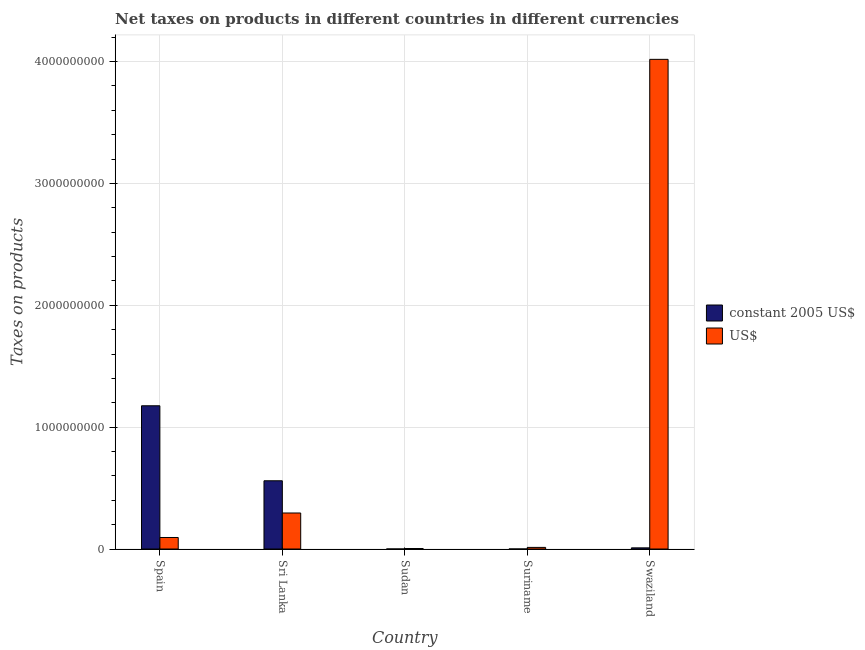How many different coloured bars are there?
Your answer should be very brief. 2. How many groups of bars are there?
Ensure brevity in your answer.  5. How many bars are there on the 3rd tick from the left?
Give a very brief answer. 2. How many bars are there on the 4th tick from the right?
Offer a very short reply. 2. What is the label of the 4th group of bars from the left?
Offer a terse response. Suriname. In how many cases, is the number of bars for a given country not equal to the number of legend labels?
Provide a succinct answer. 0. What is the net taxes in us$ in Sri Lanka?
Offer a terse response. 2.96e+08. Across all countries, what is the maximum net taxes in us$?
Provide a succinct answer. 4.02e+09. Across all countries, what is the minimum net taxes in us$?
Offer a terse response. 4.10e+06. In which country was the net taxes in constant 2005 us$ maximum?
Your answer should be very brief. Spain. In which country was the net taxes in us$ minimum?
Your answer should be compact. Sudan. What is the total net taxes in us$ in the graph?
Your response must be concise. 4.43e+09. What is the difference between the net taxes in constant 2005 us$ in Sudan and that in Swaziland?
Offer a very short reply. -9.30e+06. What is the difference between the net taxes in us$ in Swaziland and the net taxes in constant 2005 us$ in Sri Lanka?
Give a very brief answer. 3.46e+09. What is the average net taxes in constant 2005 us$ per country?
Ensure brevity in your answer.  3.49e+08. What is the difference between the net taxes in constant 2005 us$ and net taxes in us$ in Swaziland?
Provide a short and direct response. -4.01e+09. What is the ratio of the net taxes in us$ in Sri Lanka to that in Swaziland?
Offer a very short reply. 0.07. Is the net taxes in constant 2005 us$ in Sri Lanka less than that in Suriname?
Keep it short and to the point. No. Is the difference between the net taxes in us$ in Spain and Swaziland greater than the difference between the net taxes in constant 2005 us$ in Spain and Swaziland?
Offer a very short reply. No. What is the difference between the highest and the second highest net taxes in us$?
Your answer should be very brief. 3.72e+09. What is the difference between the highest and the lowest net taxes in us$?
Your answer should be compact. 4.01e+09. In how many countries, is the net taxes in us$ greater than the average net taxes in us$ taken over all countries?
Offer a very short reply. 1. Is the sum of the net taxes in us$ in Sudan and Suriname greater than the maximum net taxes in constant 2005 us$ across all countries?
Your answer should be very brief. No. What does the 1st bar from the left in Sudan represents?
Make the answer very short. Constant 2005 us$. What does the 2nd bar from the right in Sri Lanka represents?
Give a very brief answer. Constant 2005 us$. How many bars are there?
Ensure brevity in your answer.  10. Are all the bars in the graph horizontal?
Make the answer very short. No. How many countries are there in the graph?
Your answer should be very brief. 5. Are the values on the major ticks of Y-axis written in scientific E-notation?
Give a very brief answer. No. Does the graph contain any zero values?
Your response must be concise. No. Does the graph contain grids?
Your response must be concise. Yes. How many legend labels are there?
Provide a succinct answer. 2. What is the title of the graph?
Your response must be concise. Net taxes on products in different countries in different currencies. What is the label or title of the X-axis?
Offer a very short reply. Country. What is the label or title of the Y-axis?
Provide a short and direct response. Taxes on products. What is the Taxes on products in constant 2005 US$ in Spain?
Make the answer very short. 1.18e+09. What is the Taxes on products in US$ in Spain?
Offer a very short reply. 9.44e+07. What is the Taxes on products in constant 2005 US$ in Sri Lanka?
Your response must be concise. 5.60e+08. What is the Taxes on products in US$ in Sri Lanka?
Offer a terse response. 2.96e+08. What is the Taxes on products in constant 2005 US$ in Sudan?
Give a very brief answer. 1.03e+05. What is the Taxes on products in US$ in Sudan?
Make the answer very short. 4.10e+06. What is the Taxes on products of constant 2005 US$ in Suriname?
Offer a terse response. 8200. What is the Taxes on products of US$ in Suriname?
Give a very brief answer. 1.31e+07. What is the Taxes on products of constant 2005 US$ in Swaziland?
Provide a short and direct response. 9.40e+06. What is the Taxes on products of US$ in Swaziland?
Keep it short and to the point. 4.02e+09. Across all countries, what is the maximum Taxes on products in constant 2005 US$?
Give a very brief answer. 1.18e+09. Across all countries, what is the maximum Taxes on products in US$?
Make the answer very short. 4.02e+09. Across all countries, what is the minimum Taxes on products of constant 2005 US$?
Provide a succinct answer. 8200. Across all countries, what is the minimum Taxes on products of US$?
Offer a terse response. 4.10e+06. What is the total Taxes on products of constant 2005 US$ in the graph?
Your response must be concise. 1.74e+09. What is the total Taxes on products of US$ in the graph?
Your answer should be very brief. 4.43e+09. What is the difference between the Taxes on products of constant 2005 US$ in Spain and that in Sri Lanka?
Provide a succinct answer. 6.15e+08. What is the difference between the Taxes on products of US$ in Spain and that in Sri Lanka?
Provide a succinct answer. -2.01e+08. What is the difference between the Taxes on products of constant 2005 US$ in Spain and that in Sudan?
Offer a very short reply. 1.18e+09. What is the difference between the Taxes on products in US$ in Spain and that in Sudan?
Provide a short and direct response. 9.03e+07. What is the difference between the Taxes on products of constant 2005 US$ in Spain and that in Suriname?
Offer a terse response. 1.18e+09. What is the difference between the Taxes on products in US$ in Spain and that in Suriname?
Keep it short and to the point. 8.13e+07. What is the difference between the Taxes on products of constant 2005 US$ in Spain and that in Swaziland?
Your response must be concise. 1.17e+09. What is the difference between the Taxes on products of US$ in Spain and that in Swaziland?
Give a very brief answer. -3.92e+09. What is the difference between the Taxes on products in constant 2005 US$ in Sri Lanka and that in Sudan?
Provide a succinct answer. 5.60e+08. What is the difference between the Taxes on products in US$ in Sri Lanka and that in Sudan?
Offer a terse response. 2.91e+08. What is the difference between the Taxes on products of constant 2005 US$ in Sri Lanka and that in Suriname?
Ensure brevity in your answer.  5.60e+08. What is the difference between the Taxes on products in US$ in Sri Lanka and that in Suriname?
Ensure brevity in your answer.  2.82e+08. What is the difference between the Taxes on products of constant 2005 US$ in Sri Lanka and that in Swaziland?
Your response must be concise. 5.51e+08. What is the difference between the Taxes on products of US$ in Sri Lanka and that in Swaziland?
Make the answer very short. -3.72e+09. What is the difference between the Taxes on products of constant 2005 US$ in Sudan and that in Suriname?
Offer a very short reply. 9.47e+04. What is the difference between the Taxes on products of US$ in Sudan and that in Suriname?
Provide a succinct answer. -9.04e+06. What is the difference between the Taxes on products of constant 2005 US$ in Sudan and that in Swaziland?
Provide a succinct answer. -9.30e+06. What is the difference between the Taxes on products in US$ in Sudan and that in Swaziland?
Offer a very short reply. -4.01e+09. What is the difference between the Taxes on products in constant 2005 US$ in Suriname and that in Swaziland?
Your answer should be very brief. -9.39e+06. What is the difference between the Taxes on products in US$ in Suriname and that in Swaziland?
Keep it short and to the point. -4.01e+09. What is the difference between the Taxes on products of constant 2005 US$ in Spain and the Taxes on products of US$ in Sri Lanka?
Your response must be concise. 8.80e+08. What is the difference between the Taxes on products of constant 2005 US$ in Spain and the Taxes on products of US$ in Sudan?
Offer a terse response. 1.17e+09. What is the difference between the Taxes on products in constant 2005 US$ in Spain and the Taxes on products in US$ in Suriname?
Keep it short and to the point. 1.16e+09. What is the difference between the Taxes on products of constant 2005 US$ in Spain and the Taxes on products of US$ in Swaziland?
Your response must be concise. -2.84e+09. What is the difference between the Taxes on products in constant 2005 US$ in Sri Lanka and the Taxes on products in US$ in Sudan?
Your answer should be very brief. 5.56e+08. What is the difference between the Taxes on products of constant 2005 US$ in Sri Lanka and the Taxes on products of US$ in Suriname?
Keep it short and to the point. 5.47e+08. What is the difference between the Taxes on products of constant 2005 US$ in Sri Lanka and the Taxes on products of US$ in Swaziland?
Ensure brevity in your answer.  -3.46e+09. What is the difference between the Taxes on products in constant 2005 US$ in Sudan and the Taxes on products in US$ in Suriname?
Your answer should be very brief. -1.30e+07. What is the difference between the Taxes on products in constant 2005 US$ in Sudan and the Taxes on products in US$ in Swaziland?
Provide a short and direct response. -4.02e+09. What is the difference between the Taxes on products of constant 2005 US$ in Suriname and the Taxes on products of US$ in Swaziland?
Give a very brief answer. -4.02e+09. What is the average Taxes on products in constant 2005 US$ per country?
Make the answer very short. 3.49e+08. What is the average Taxes on products in US$ per country?
Provide a short and direct response. 8.85e+08. What is the difference between the Taxes on products of constant 2005 US$ and Taxes on products of US$ in Spain?
Offer a very short reply. 1.08e+09. What is the difference between the Taxes on products of constant 2005 US$ and Taxes on products of US$ in Sri Lanka?
Offer a terse response. 2.64e+08. What is the difference between the Taxes on products in constant 2005 US$ and Taxes on products in US$ in Sudan?
Provide a succinct answer. -4.00e+06. What is the difference between the Taxes on products in constant 2005 US$ and Taxes on products in US$ in Suriname?
Give a very brief answer. -1.31e+07. What is the difference between the Taxes on products of constant 2005 US$ and Taxes on products of US$ in Swaziland?
Give a very brief answer. -4.01e+09. What is the ratio of the Taxes on products in constant 2005 US$ in Spain to that in Sri Lanka?
Give a very brief answer. 2.1. What is the ratio of the Taxes on products of US$ in Spain to that in Sri Lanka?
Offer a terse response. 0.32. What is the ratio of the Taxes on products in constant 2005 US$ in Spain to that in Sudan?
Keep it short and to the point. 1.14e+04. What is the ratio of the Taxes on products in US$ in Spain to that in Sudan?
Your answer should be compact. 23.03. What is the ratio of the Taxes on products of constant 2005 US$ in Spain to that in Suriname?
Give a very brief answer. 1.43e+05. What is the ratio of the Taxes on products in US$ in Spain to that in Suriname?
Keep it short and to the point. 7.19. What is the ratio of the Taxes on products of constant 2005 US$ in Spain to that in Swaziland?
Offer a very short reply. 125.05. What is the ratio of the Taxes on products in US$ in Spain to that in Swaziland?
Ensure brevity in your answer.  0.02. What is the ratio of the Taxes on products in constant 2005 US$ in Sri Lanka to that in Sudan?
Your answer should be compact. 5442.18. What is the ratio of the Taxes on products of US$ in Sri Lanka to that in Sudan?
Provide a succinct answer. 72.08. What is the ratio of the Taxes on products of constant 2005 US$ in Sri Lanka to that in Suriname?
Your answer should be compact. 6.83e+04. What is the ratio of the Taxes on products of US$ in Sri Lanka to that in Suriname?
Your response must be concise. 22.49. What is the ratio of the Taxes on products in constant 2005 US$ in Sri Lanka to that in Swaziland?
Offer a very short reply. 59.57. What is the ratio of the Taxes on products in US$ in Sri Lanka to that in Swaziland?
Make the answer very short. 0.07. What is the ratio of the Taxes on products of constant 2005 US$ in Sudan to that in Suriname?
Provide a short and direct response. 12.55. What is the ratio of the Taxes on products in US$ in Sudan to that in Suriname?
Provide a succinct answer. 0.31. What is the ratio of the Taxes on products in constant 2005 US$ in Sudan to that in Swaziland?
Your answer should be very brief. 0.01. What is the ratio of the Taxes on products of US$ in Sudan to that in Swaziland?
Give a very brief answer. 0. What is the ratio of the Taxes on products in constant 2005 US$ in Suriname to that in Swaziland?
Give a very brief answer. 0. What is the ratio of the Taxes on products in US$ in Suriname to that in Swaziland?
Your answer should be very brief. 0. What is the difference between the highest and the second highest Taxes on products of constant 2005 US$?
Ensure brevity in your answer.  6.15e+08. What is the difference between the highest and the second highest Taxes on products of US$?
Make the answer very short. 3.72e+09. What is the difference between the highest and the lowest Taxes on products of constant 2005 US$?
Provide a short and direct response. 1.18e+09. What is the difference between the highest and the lowest Taxes on products of US$?
Your answer should be very brief. 4.01e+09. 